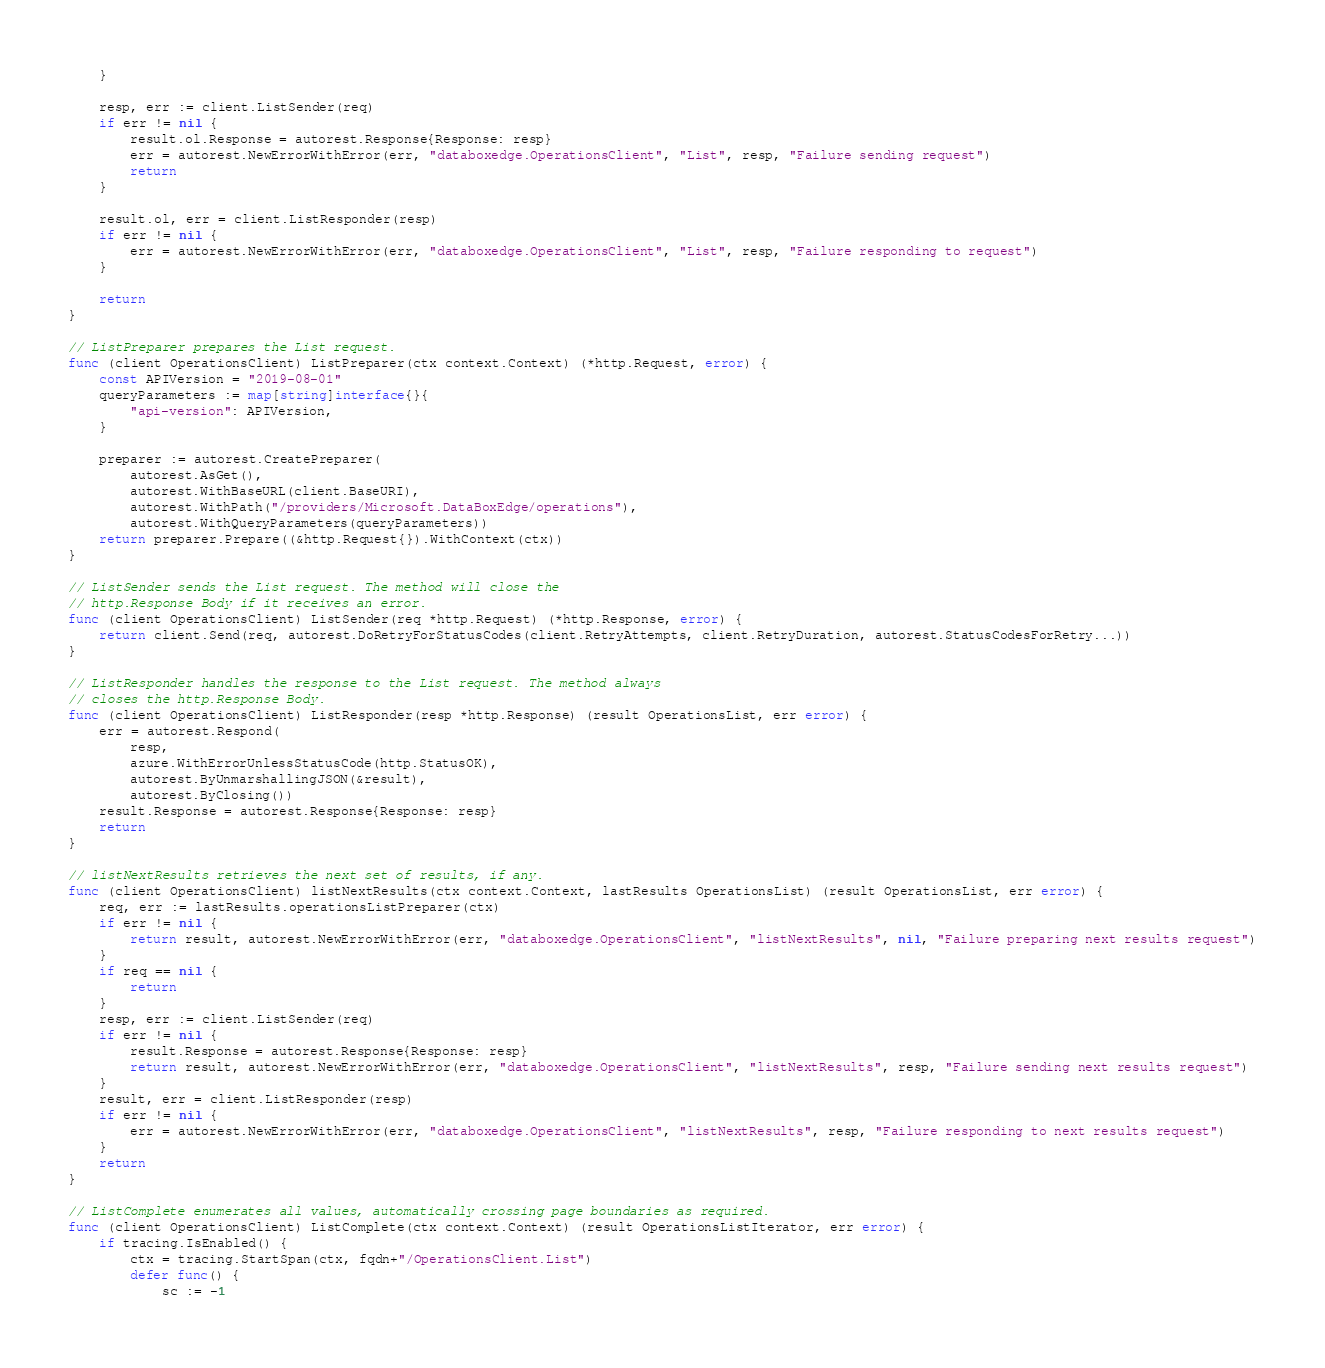<code> <loc_0><loc_0><loc_500><loc_500><_Go_>	}

	resp, err := client.ListSender(req)
	if err != nil {
		result.ol.Response = autorest.Response{Response: resp}
		err = autorest.NewErrorWithError(err, "databoxedge.OperationsClient", "List", resp, "Failure sending request")
		return
	}

	result.ol, err = client.ListResponder(resp)
	if err != nil {
		err = autorest.NewErrorWithError(err, "databoxedge.OperationsClient", "List", resp, "Failure responding to request")
	}

	return
}

// ListPreparer prepares the List request.
func (client OperationsClient) ListPreparer(ctx context.Context) (*http.Request, error) {
	const APIVersion = "2019-08-01"
	queryParameters := map[string]interface{}{
		"api-version": APIVersion,
	}

	preparer := autorest.CreatePreparer(
		autorest.AsGet(),
		autorest.WithBaseURL(client.BaseURI),
		autorest.WithPath("/providers/Microsoft.DataBoxEdge/operations"),
		autorest.WithQueryParameters(queryParameters))
	return preparer.Prepare((&http.Request{}).WithContext(ctx))
}

// ListSender sends the List request. The method will close the
// http.Response Body if it receives an error.
func (client OperationsClient) ListSender(req *http.Request) (*http.Response, error) {
	return client.Send(req, autorest.DoRetryForStatusCodes(client.RetryAttempts, client.RetryDuration, autorest.StatusCodesForRetry...))
}

// ListResponder handles the response to the List request. The method always
// closes the http.Response Body.
func (client OperationsClient) ListResponder(resp *http.Response) (result OperationsList, err error) {
	err = autorest.Respond(
		resp,
		azure.WithErrorUnlessStatusCode(http.StatusOK),
		autorest.ByUnmarshallingJSON(&result),
		autorest.ByClosing())
	result.Response = autorest.Response{Response: resp}
	return
}

// listNextResults retrieves the next set of results, if any.
func (client OperationsClient) listNextResults(ctx context.Context, lastResults OperationsList) (result OperationsList, err error) {
	req, err := lastResults.operationsListPreparer(ctx)
	if err != nil {
		return result, autorest.NewErrorWithError(err, "databoxedge.OperationsClient", "listNextResults", nil, "Failure preparing next results request")
	}
	if req == nil {
		return
	}
	resp, err := client.ListSender(req)
	if err != nil {
		result.Response = autorest.Response{Response: resp}
		return result, autorest.NewErrorWithError(err, "databoxedge.OperationsClient", "listNextResults", resp, "Failure sending next results request")
	}
	result, err = client.ListResponder(resp)
	if err != nil {
		err = autorest.NewErrorWithError(err, "databoxedge.OperationsClient", "listNextResults", resp, "Failure responding to next results request")
	}
	return
}

// ListComplete enumerates all values, automatically crossing page boundaries as required.
func (client OperationsClient) ListComplete(ctx context.Context) (result OperationsListIterator, err error) {
	if tracing.IsEnabled() {
		ctx = tracing.StartSpan(ctx, fqdn+"/OperationsClient.List")
		defer func() {
			sc := -1</code> 